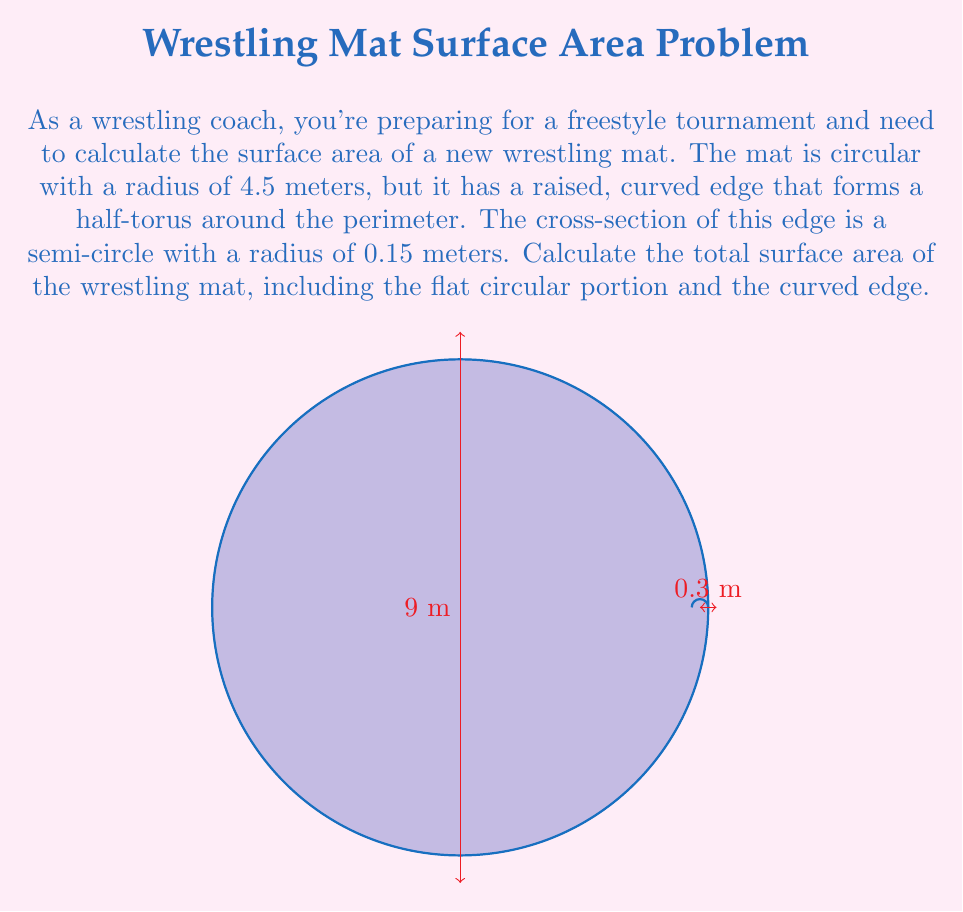Provide a solution to this math problem. Let's break this problem down into steps:

1) First, we need to calculate the area of the flat circular portion of the mat:
   $$A_{circle} = \pi r^2 = \pi (4.5)^2 = 63.62 \text{ m}^2$$

2) Next, we need to calculate the surface area of the curved edge. This edge forms a half-torus around the perimeter of the mat. The surface area of a torus is given by the formula:
   $$A_{torus} = 4\pi^2 Rr$$
   where R is the distance from the center of the tube to the center of the torus, and r is the radius of the tube.

3) In our case, R = 4.5 m (the radius of the mat) and r = 0.15 m (the radius of the edge cross-section). However, we only have half of a torus, so we'll divide the result by 2:
   $$A_{edge} = \frac{1}{2} (4\pi^2 Rr) = 2\pi^2 (4.5)(0.15) = 13.35 \text{ m}^2$$

4) Finally, we need to add the area of the flat top surface of the edge. This is a thin strip that goes around the perimeter of the mat. Its width is the radius of the edge cross-section (0.15 m) and its length is the circumference of the mat:
   $$A_{strip} = 2\pi R (0.15) = 2\pi (4.5)(0.15) = 4.24 \text{ m}^2$$

5) The total surface area is the sum of all these parts:
   $$A_{total} = A_{circle} + A_{edge} + A_{strip} = 63.62 + 13.35 + 4.24 = 81.21 \text{ m}^2$$
Answer: 81.21 m² 